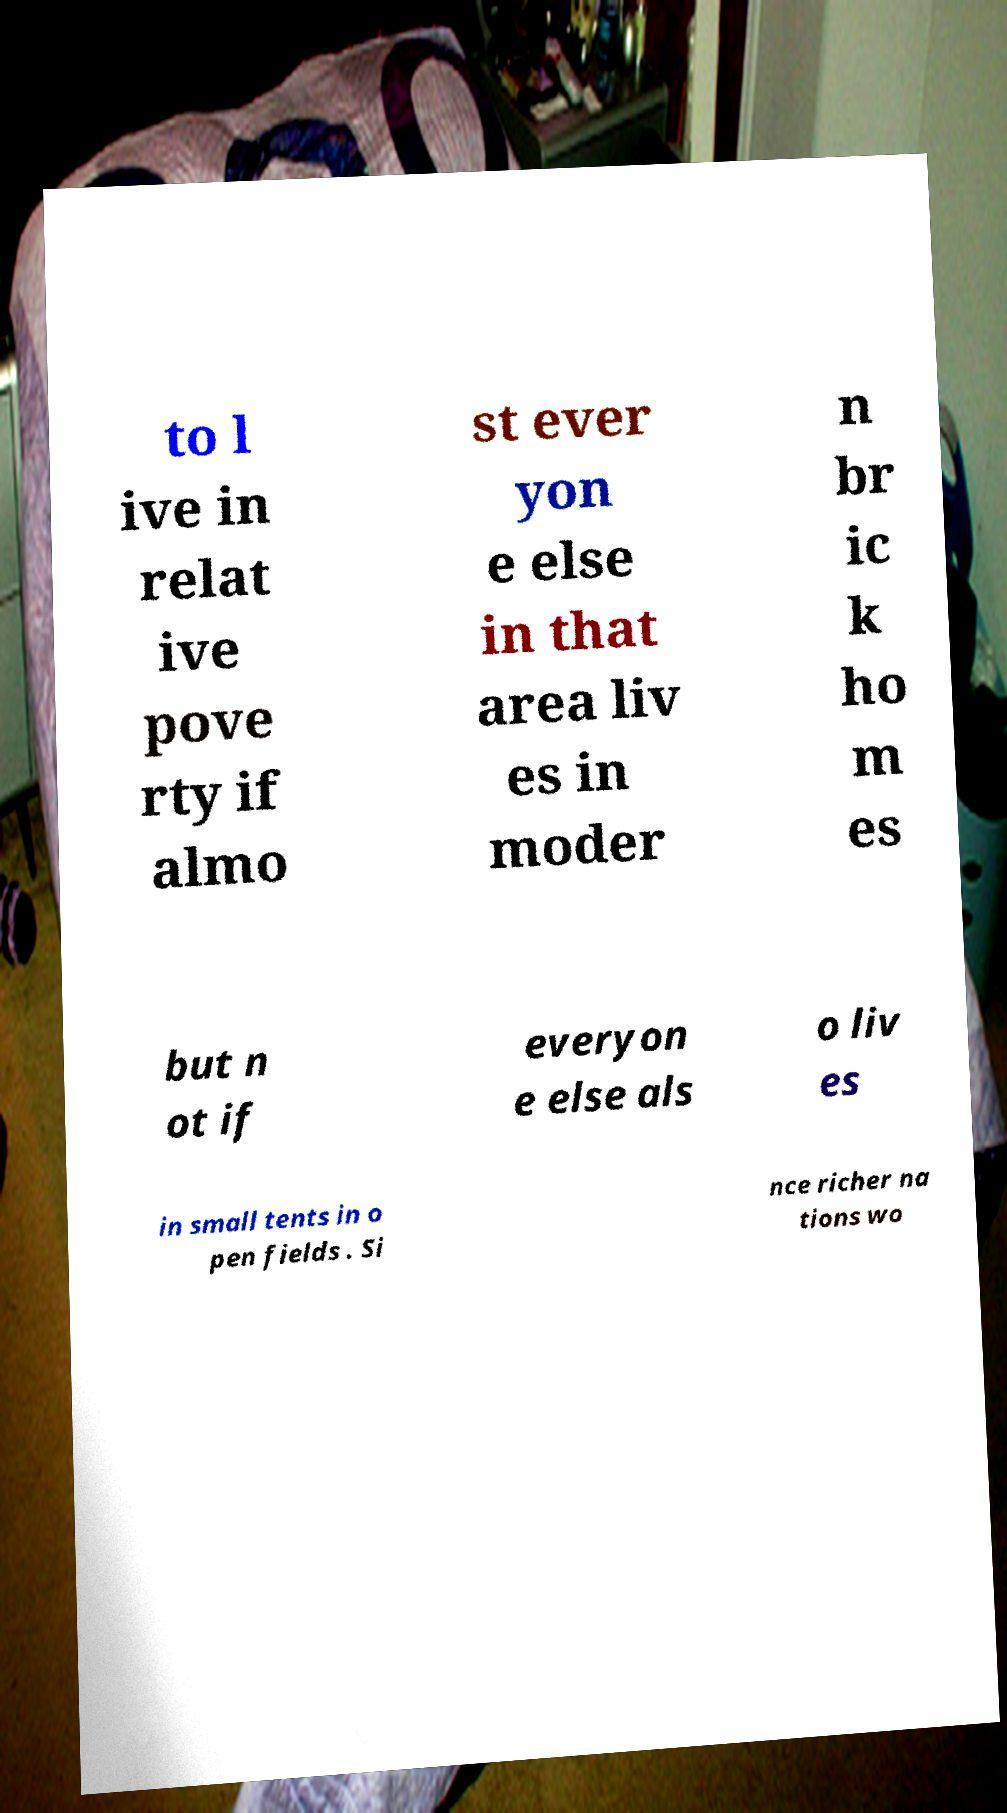I need the written content from this picture converted into text. Can you do that? to l ive in relat ive pove rty if almo st ever yon e else in that area liv es in moder n br ic k ho m es but n ot if everyon e else als o liv es in small tents in o pen fields . Si nce richer na tions wo 